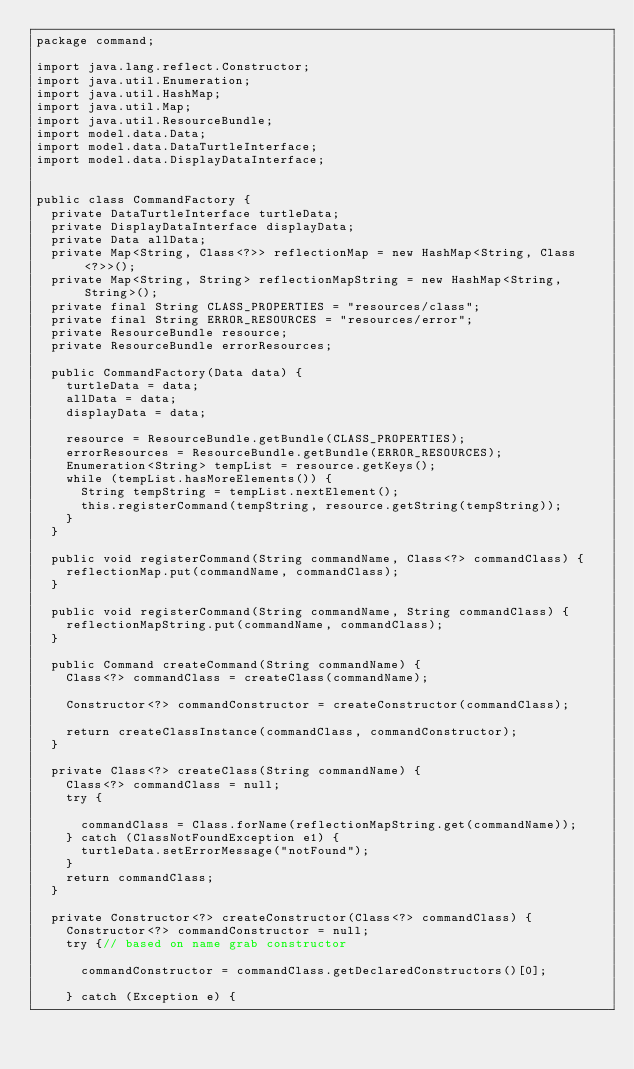<code> <loc_0><loc_0><loc_500><loc_500><_Java_>package command;

import java.lang.reflect.Constructor;
import java.util.Enumeration;
import java.util.HashMap;
import java.util.Map;
import java.util.ResourceBundle;
import model.data.Data;
import model.data.DataTurtleInterface;
import model.data.DisplayDataInterface;


public class CommandFactory {
  private DataTurtleInterface turtleData;
  private DisplayDataInterface displayData;
  private Data allData;
  private Map<String, Class<?>> reflectionMap = new HashMap<String, Class<?>>();
  private Map<String, String> reflectionMapString = new HashMap<String, String>();
  private final String CLASS_PROPERTIES = "resources/class";
  private final String ERROR_RESOURCES = "resources/error";
  private ResourceBundle resource;
  private ResourceBundle errorResources;

  public CommandFactory(Data data) {
    turtleData = data;
    allData = data;
    displayData = data;

    resource = ResourceBundle.getBundle(CLASS_PROPERTIES);
    errorResources = ResourceBundle.getBundle(ERROR_RESOURCES);
    Enumeration<String> tempList = resource.getKeys();
    while (tempList.hasMoreElements()) {
      String tempString = tempList.nextElement();
      this.registerCommand(tempString, resource.getString(tempString));
    }
  }

  public void registerCommand(String commandName, Class<?> commandClass) {
    reflectionMap.put(commandName, commandClass);
  }

  public void registerCommand(String commandName, String commandClass) {
    reflectionMapString.put(commandName, commandClass);
  }

  public Command createCommand(String commandName) {
    Class<?> commandClass = createClass(commandName);

    Constructor<?> commandConstructor = createConstructor(commandClass);

    return createClassInstance(commandClass, commandConstructor);
  }

  private Class<?> createClass(String commandName) {
    Class<?> commandClass = null;
    try {

      commandClass = Class.forName(reflectionMapString.get(commandName));
    } catch (ClassNotFoundException e1) {
      turtleData.setErrorMessage("notFound");
    }
    return commandClass;
  }

  private Constructor<?> createConstructor(Class<?> commandClass) {
    Constructor<?> commandConstructor = null;
    try {// based on name grab constructor

      commandConstructor = commandClass.getDeclaredConstructors()[0];

    } catch (Exception e) {</code> 